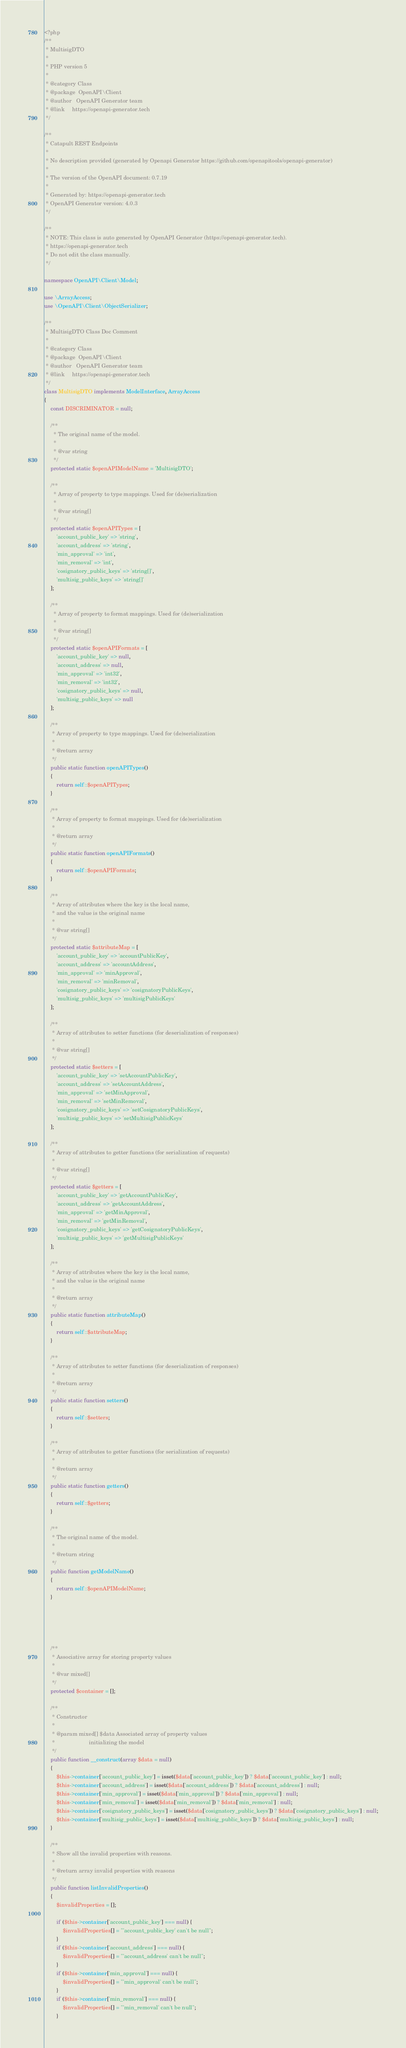<code> <loc_0><loc_0><loc_500><loc_500><_PHP_><?php
/**
 * MultisigDTO
 *
 * PHP version 5
 *
 * @category Class
 * @package  OpenAPI\Client
 * @author   OpenAPI Generator team
 * @link     https://openapi-generator.tech
 */

/**
 * Catapult REST Endpoints
 *
 * No description provided (generated by Openapi Generator https://github.com/openapitools/openapi-generator)
 *
 * The version of the OpenAPI document: 0.7.19
 * 
 * Generated by: https://openapi-generator.tech
 * OpenAPI Generator version: 4.0.3
 */

/**
 * NOTE: This class is auto generated by OpenAPI Generator (https://openapi-generator.tech).
 * https://openapi-generator.tech
 * Do not edit the class manually.
 */

namespace OpenAPI\Client\Model;

use \ArrayAccess;
use \OpenAPI\Client\ObjectSerializer;

/**
 * MultisigDTO Class Doc Comment
 *
 * @category Class
 * @package  OpenAPI\Client
 * @author   OpenAPI Generator team
 * @link     https://openapi-generator.tech
 */
class MultisigDTO implements ModelInterface, ArrayAccess
{
    const DISCRIMINATOR = null;

    /**
      * The original name of the model.
      *
      * @var string
      */
    protected static $openAPIModelName = 'MultisigDTO';

    /**
      * Array of property to type mappings. Used for (de)serialization
      *
      * @var string[]
      */
    protected static $openAPITypes = [
        'account_public_key' => 'string',
        'account_address' => 'string',
        'min_approval' => 'int',
        'min_removal' => 'int',
        'cosignatory_public_keys' => 'string[]',
        'multisig_public_keys' => 'string[]'
    ];

    /**
      * Array of property to format mappings. Used for (de)serialization
      *
      * @var string[]
      */
    protected static $openAPIFormats = [
        'account_public_key' => null,
        'account_address' => null,
        'min_approval' => 'int32',
        'min_removal' => 'int32',
        'cosignatory_public_keys' => null,
        'multisig_public_keys' => null
    ];

    /**
     * Array of property to type mappings. Used for (de)serialization
     *
     * @return array
     */
    public static function openAPITypes()
    {
        return self::$openAPITypes;
    }

    /**
     * Array of property to format mappings. Used for (de)serialization
     *
     * @return array
     */
    public static function openAPIFormats()
    {
        return self::$openAPIFormats;
    }

    /**
     * Array of attributes where the key is the local name,
     * and the value is the original name
     *
     * @var string[]
     */
    protected static $attributeMap = [
        'account_public_key' => 'accountPublicKey',
        'account_address' => 'accountAddress',
        'min_approval' => 'minApproval',
        'min_removal' => 'minRemoval',
        'cosignatory_public_keys' => 'cosignatoryPublicKeys',
        'multisig_public_keys' => 'multisigPublicKeys'
    ];

    /**
     * Array of attributes to setter functions (for deserialization of responses)
     *
     * @var string[]
     */
    protected static $setters = [
        'account_public_key' => 'setAccountPublicKey',
        'account_address' => 'setAccountAddress',
        'min_approval' => 'setMinApproval',
        'min_removal' => 'setMinRemoval',
        'cosignatory_public_keys' => 'setCosignatoryPublicKeys',
        'multisig_public_keys' => 'setMultisigPublicKeys'
    ];

    /**
     * Array of attributes to getter functions (for serialization of requests)
     *
     * @var string[]
     */
    protected static $getters = [
        'account_public_key' => 'getAccountPublicKey',
        'account_address' => 'getAccountAddress',
        'min_approval' => 'getMinApproval',
        'min_removal' => 'getMinRemoval',
        'cosignatory_public_keys' => 'getCosignatoryPublicKeys',
        'multisig_public_keys' => 'getMultisigPublicKeys'
    ];

    /**
     * Array of attributes where the key is the local name,
     * and the value is the original name
     *
     * @return array
     */
    public static function attributeMap()
    {
        return self::$attributeMap;
    }

    /**
     * Array of attributes to setter functions (for deserialization of responses)
     *
     * @return array
     */
    public static function setters()
    {
        return self::$setters;
    }

    /**
     * Array of attributes to getter functions (for serialization of requests)
     *
     * @return array
     */
    public static function getters()
    {
        return self::$getters;
    }

    /**
     * The original name of the model.
     *
     * @return string
     */
    public function getModelName()
    {
        return self::$openAPIModelName;
    }

    

    

    /**
     * Associative array for storing property values
     *
     * @var mixed[]
     */
    protected $container = [];

    /**
     * Constructor
     *
     * @param mixed[] $data Associated array of property values
     *                      initializing the model
     */
    public function __construct(array $data = null)
    {
        $this->container['account_public_key'] = isset($data['account_public_key']) ? $data['account_public_key'] : null;
        $this->container['account_address'] = isset($data['account_address']) ? $data['account_address'] : null;
        $this->container['min_approval'] = isset($data['min_approval']) ? $data['min_approval'] : null;
        $this->container['min_removal'] = isset($data['min_removal']) ? $data['min_removal'] : null;
        $this->container['cosignatory_public_keys'] = isset($data['cosignatory_public_keys']) ? $data['cosignatory_public_keys'] : null;
        $this->container['multisig_public_keys'] = isset($data['multisig_public_keys']) ? $data['multisig_public_keys'] : null;
    }

    /**
     * Show all the invalid properties with reasons.
     *
     * @return array invalid properties with reasons
     */
    public function listInvalidProperties()
    {
        $invalidProperties = [];

        if ($this->container['account_public_key'] === null) {
            $invalidProperties[] = "'account_public_key' can't be null";
        }
        if ($this->container['account_address'] === null) {
            $invalidProperties[] = "'account_address' can't be null";
        }
        if ($this->container['min_approval'] === null) {
            $invalidProperties[] = "'min_approval' can't be null";
        }
        if ($this->container['min_removal'] === null) {
            $invalidProperties[] = "'min_removal' can't be null";
        }</code> 